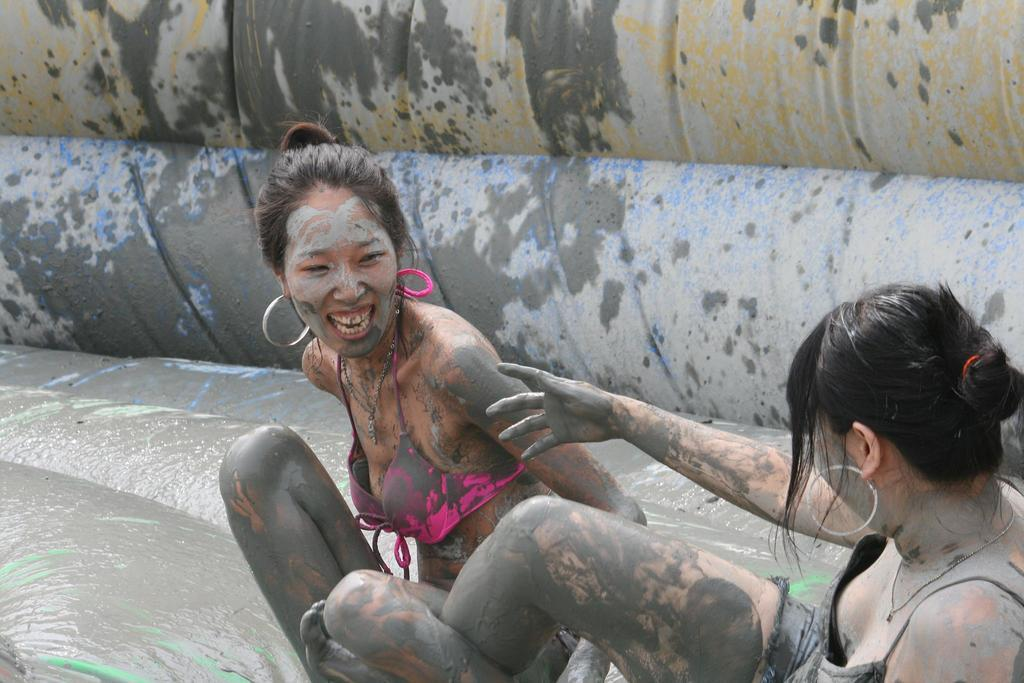How many people are in the image? There are two lady persons in the image. What are the lady persons wearing? The lady persons are wearing bikinis. What activity are the lady persons engaged in? The lady persons are playing in a semi-solid substance, which is black in color. What can be seen in the background of the image? There is a yellow and blue color sheet in the background of the image. What type of stove is visible in the image? There is no stove present in the image. How many balloons are being held by the lady persons in the image? There are no balloons visible in the image. 